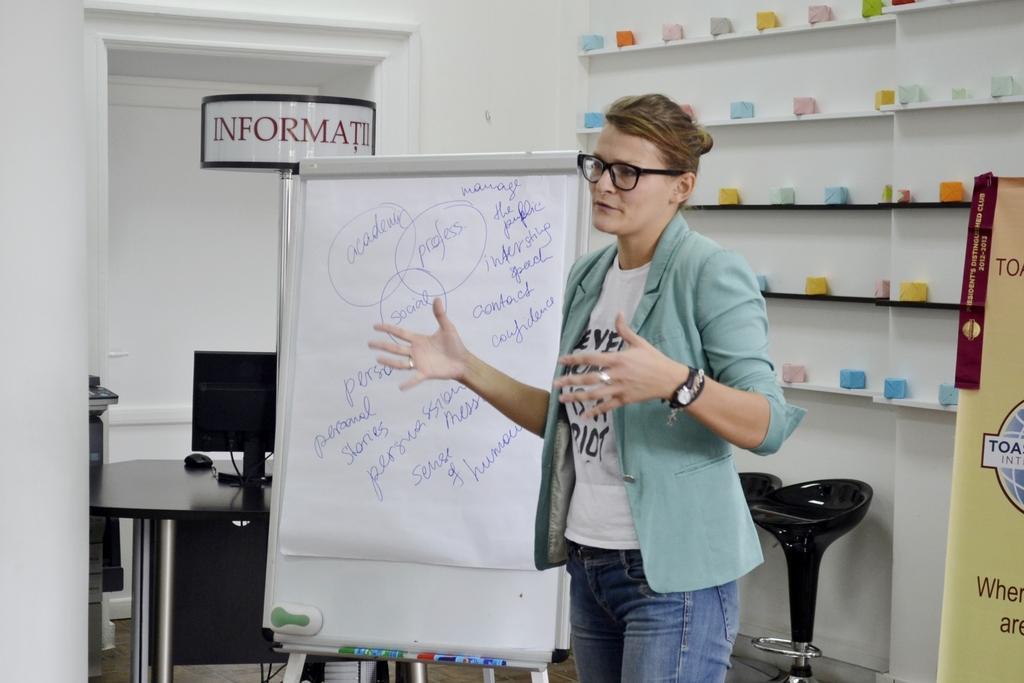Please provide a concise description of this image. There is a women standing and there is a board beside her which has something written on it and there is a shelf behind her which has some objects on it. 